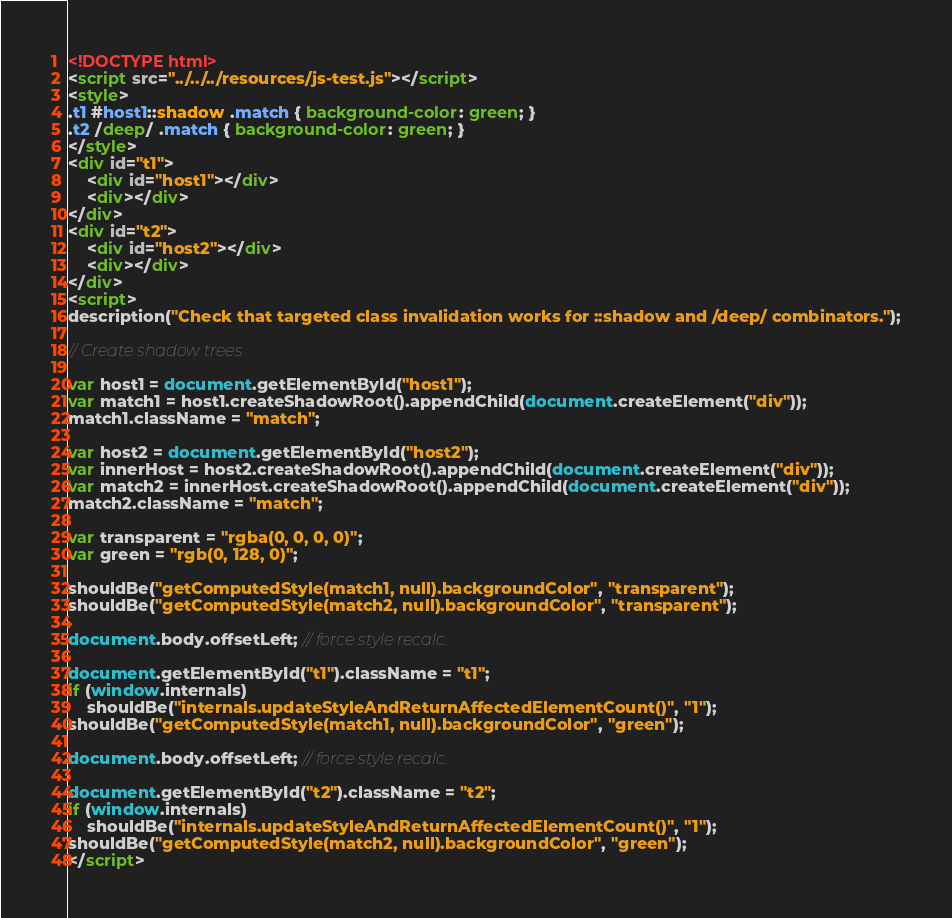Convert code to text. <code><loc_0><loc_0><loc_500><loc_500><_HTML_><!DOCTYPE html>
<script src="../../../resources/js-test.js"></script>
<style>
.t1 #host1::shadow .match { background-color: green; }
.t2 /deep/ .match { background-color: green; }
</style>
<div id="t1">
    <div id="host1"></div>
    <div></div>
</div>
<div id="t2">
    <div id="host2"></div>
    <div></div>
</div>
<script>
description("Check that targeted class invalidation works for ::shadow and /deep/ combinators.");

// Create shadow trees

var host1 = document.getElementById("host1");
var match1 = host1.createShadowRoot().appendChild(document.createElement("div"));
match1.className = "match";

var host2 = document.getElementById("host2");
var innerHost = host2.createShadowRoot().appendChild(document.createElement("div"));
var match2 = innerHost.createShadowRoot().appendChild(document.createElement("div"));
match2.className = "match";

var transparent = "rgba(0, 0, 0, 0)";
var green = "rgb(0, 128, 0)";

shouldBe("getComputedStyle(match1, null).backgroundColor", "transparent");
shouldBe("getComputedStyle(match2, null).backgroundColor", "transparent");

document.body.offsetLeft; // force style recalc.

document.getElementById("t1").className = "t1";
if (window.internals)
    shouldBe("internals.updateStyleAndReturnAffectedElementCount()", "1");
shouldBe("getComputedStyle(match1, null).backgroundColor", "green");

document.body.offsetLeft; // force style recalc.

document.getElementById("t2").className = "t2";
if (window.internals)
    shouldBe("internals.updateStyleAndReturnAffectedElementCount()", "1");
shouldBe("getComputedStyle(match2, null).backgroundColor", "green");
</script>
</code> 